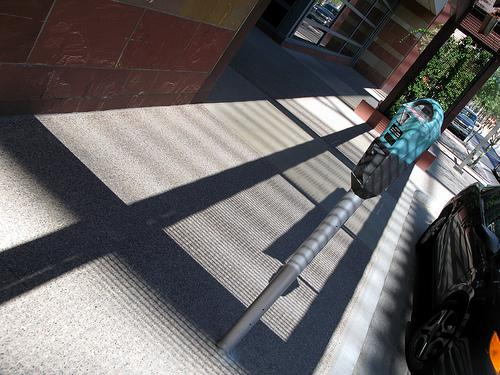Question: where was the picture taken?
Choices:
A. On the sidewalk.
B. On the street.
C. On the highway.
D. At the circus.
Answer with the letter. Answer: A Question: who is in the picture?
Choices:
A. Elvis.
B. Beyonce.
C. No one.
D. Obama.
Answer with the letter. Answer: C 